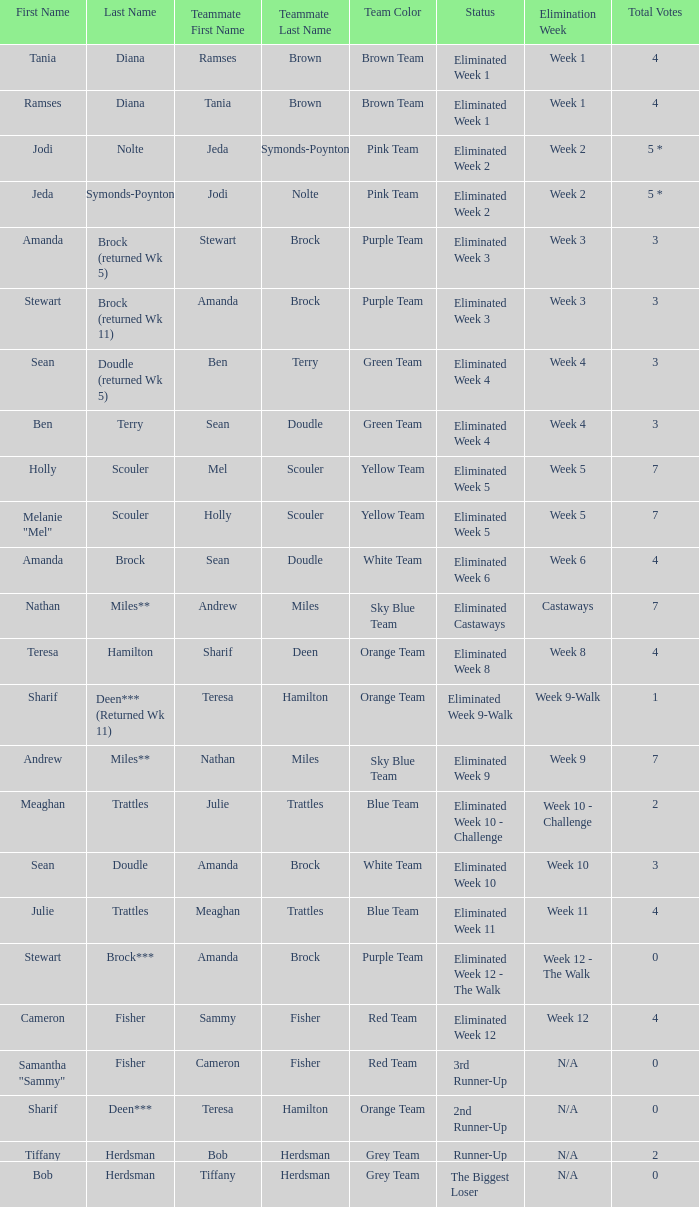What was Holly Scouler's total votes 7.0. 